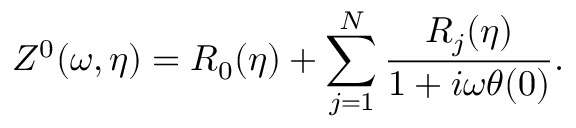<formula> <loc_0><loc_0><loc_500><loc_500>Z ^ { 0 } ( \omega , \eta ) = R _ { 0 } ( \eta ) + \sum _ { j = 1 } ^ { N } \frac { R _ { j } ( \eta ) } { 1 + i \omega \theta ( 0 ) } .</formula> 